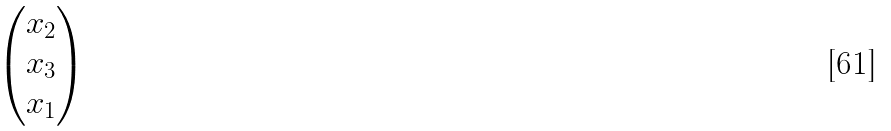Convert formula to latex. <formula><loc_0><loc_0><loc_500><loc_500>\begin{pmatrix} x _ { 2 } \\ x _ { 3 } \\ x _ { 1 } \end{pmatrix}</formula> 